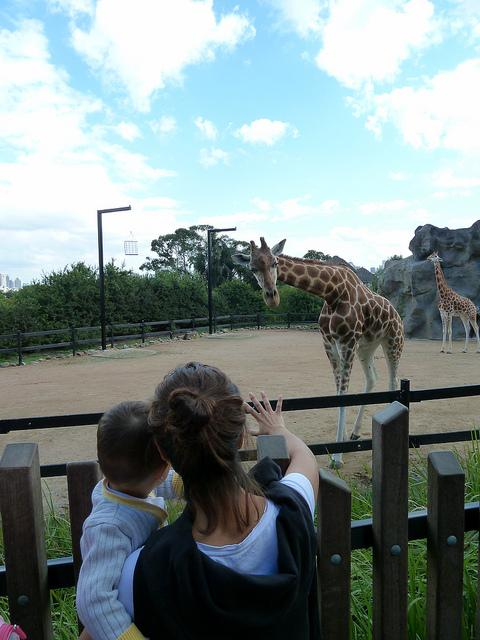What is the hanging basket for? food 